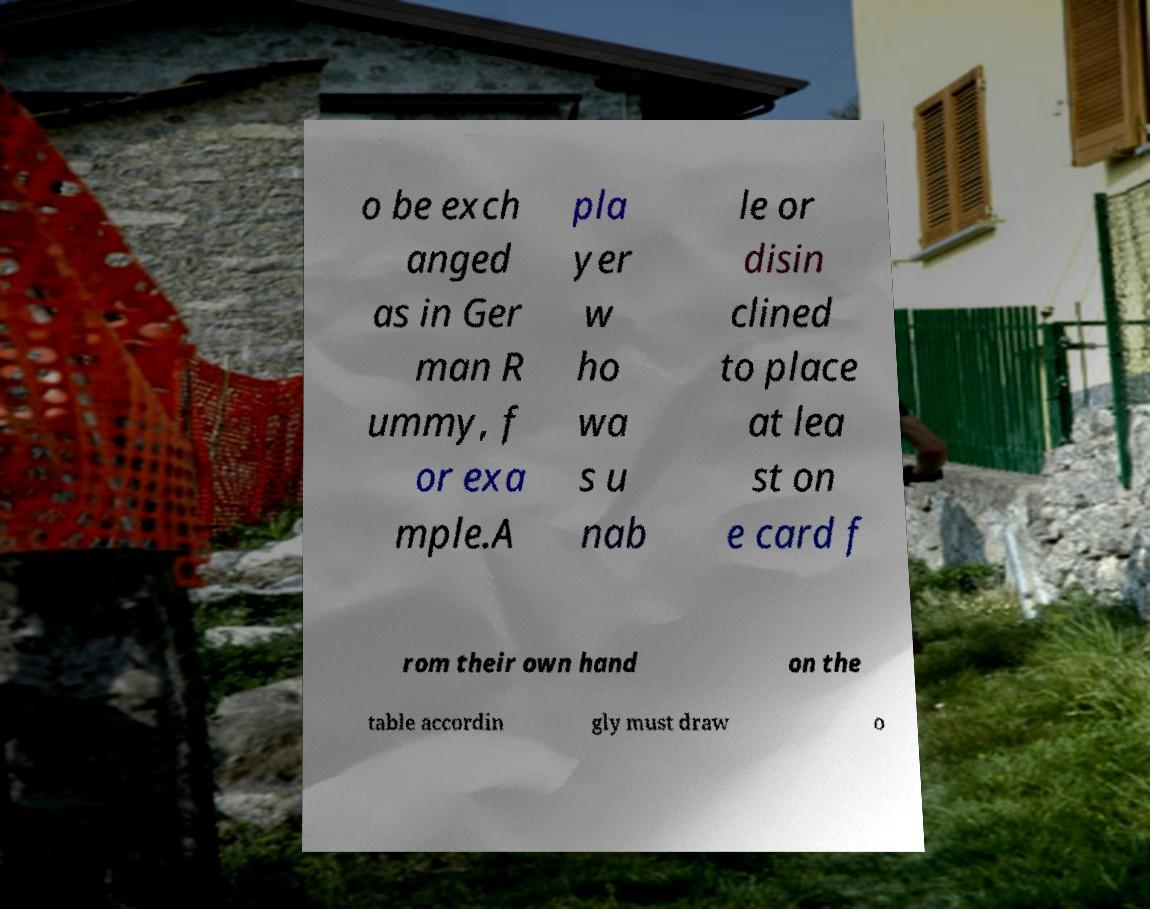What messages or text are displayed in this image? I need them in a readable, typed format. o be exch anged as in Ger man R ummy, f or exa mple.A pla yer w ho wa s u nab le or disin clined to place at lea st on e card f rom their own hand on the table accordin gly must draw o 